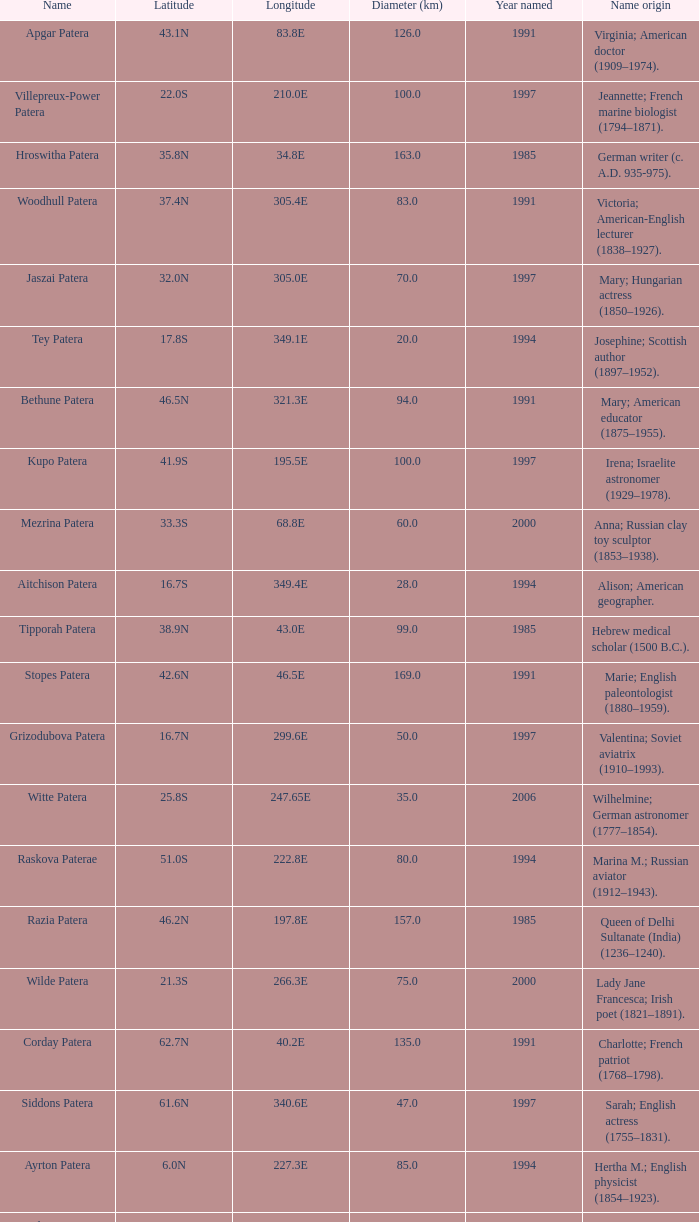In what year was the feature at a 33.3S latitude named?  2000.0. 